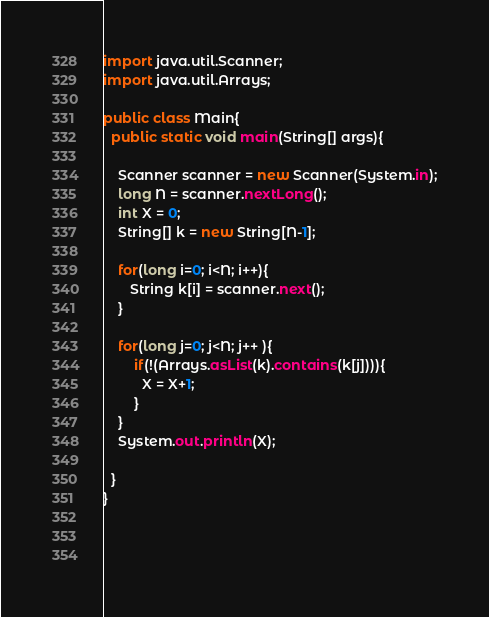Convert code to text. <code><loc_0><loc_0><loc_500><loc_500><_Java_>import java.util.Scanner;
import java.util.Arrays;

public class Main{
  public static void main(String[] args){
    
    Scanner scanner = new Scanner(System.in);
    long N = scanner.nextLong();
    int X = 0;
    String[] k = new String[N-1];
      
    for(long i=0; i<N; i++){
       String k[i] = scanner.next();
    }
    
    for(long j=0; j<N; j++ ){
        if(!(Arrays.asList(k).contains(k[j]))){
          X = X+1;
        }
    }
    System.out.println(X);
    
  }
}

    
    
</code> 